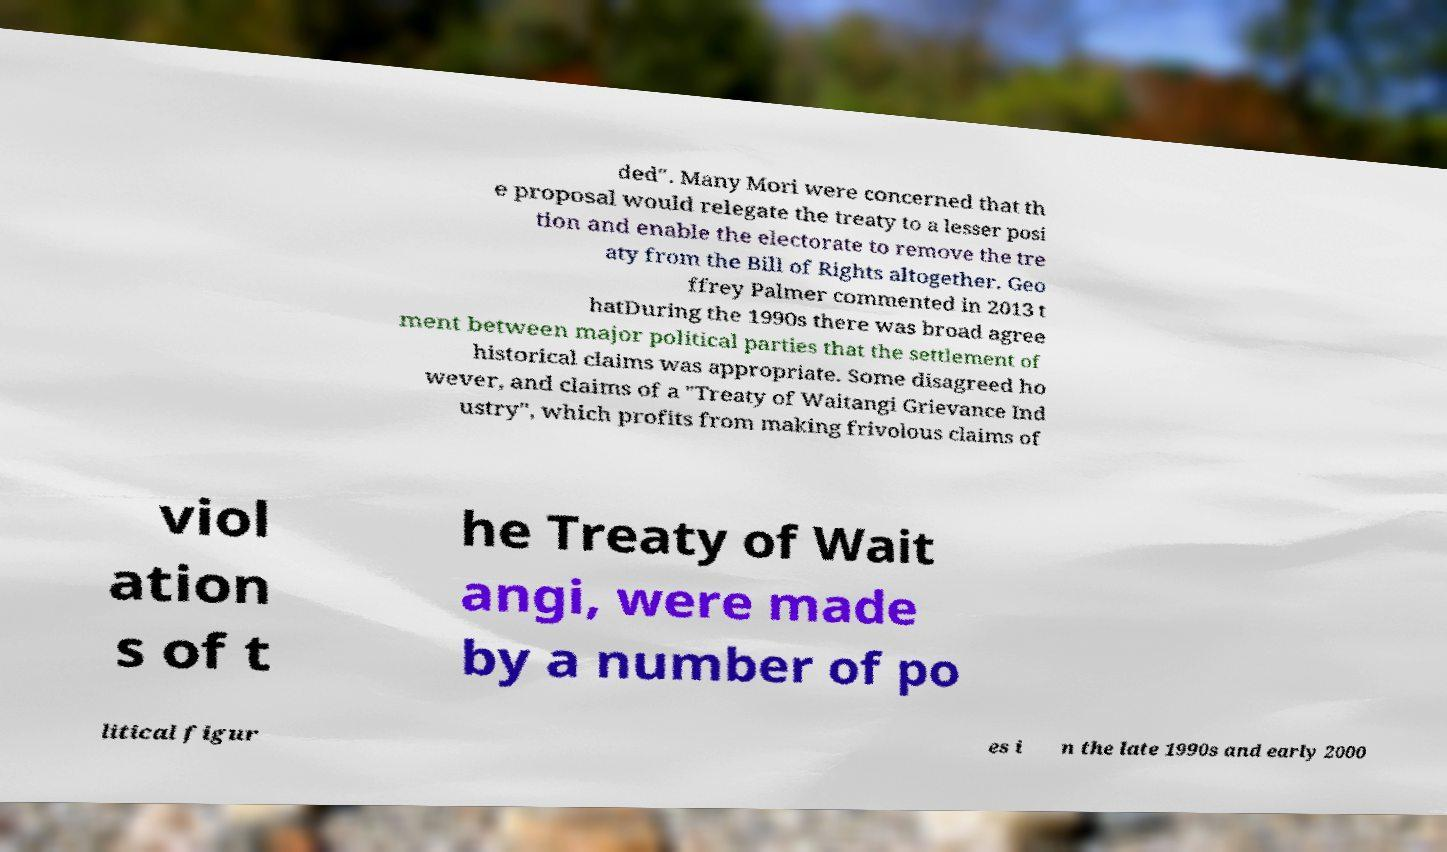Please identify and transcribe the text found in this image. ded". Many Mori were concerned that th e proposal would relegate the treaty to a lesser posi tion and enable the electorate to remove the tre aty from the Bill of Rights altogether. Geo ffrey Palmer commented in 2013 t hatDuring the 1990s there was broad agree ment between major political parties that the settlement of historical claims was appropriate. Some disagreed ho wever, and claims of a "Treaty of Waitangi Grievance Ind ustry", which profits from making frivolous claims of viol ation s of t he Treaty of Wait angi, were made by a number of po litical figur es i n the late 1990s and early 2000 